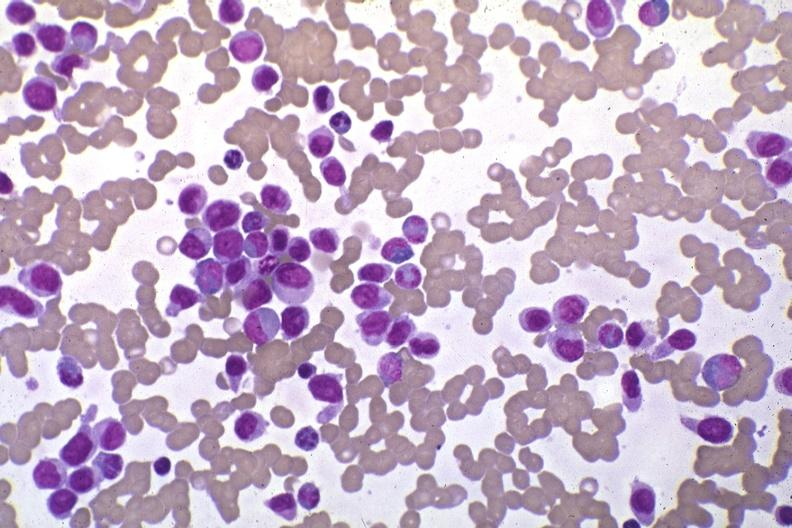does this image show wrights stain pleomorphic leukemic cells in peripheral blood prior to therapy?
Answer the question using a single word or phrase. Yes 